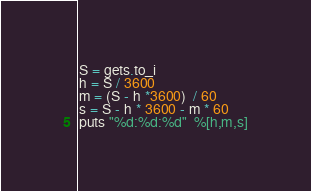Convert code to text. <code><loc_0><loc_0><loc_500><loc_500><_Ruby_>S = gets.to_i
h = S / 3600
m = (S - h *3600)  / 60
s = S - h * 3600 - m * 60
puts "%d:%d:%d"  %[h,m,s]</code> 